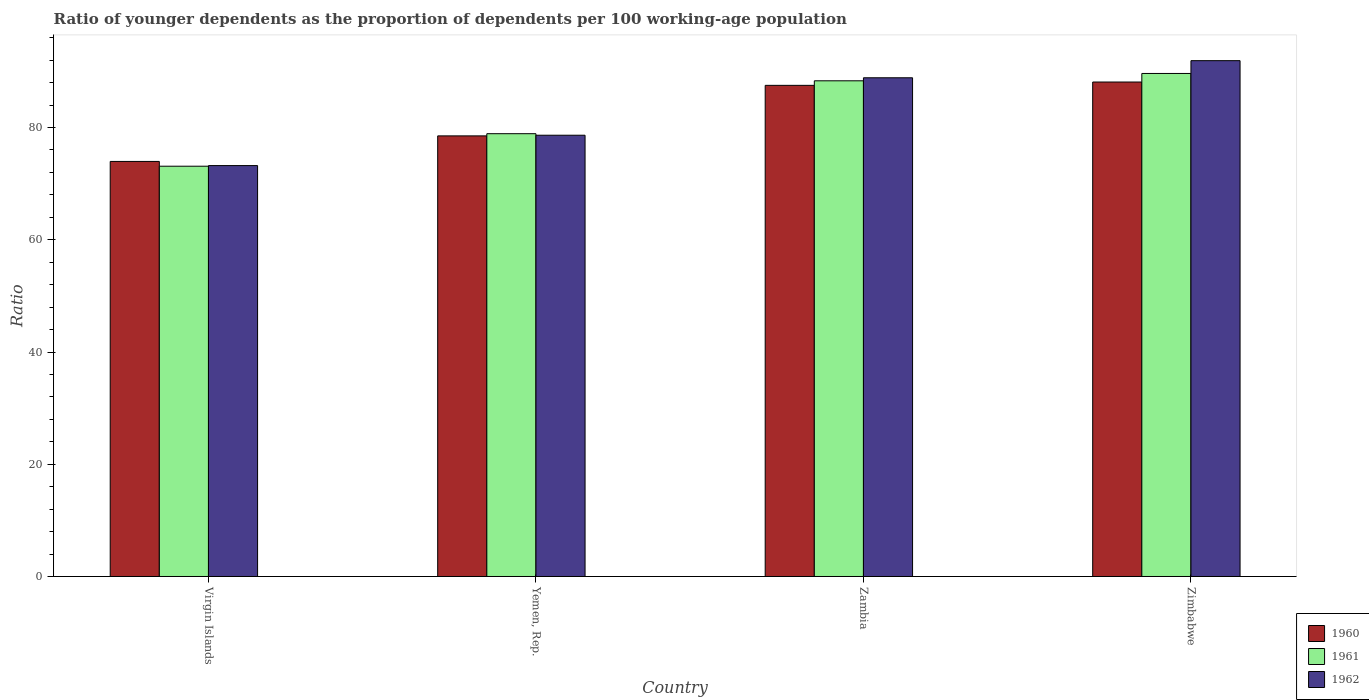How many groups of bars are there?
Ensure brevity in your answer.  4. Are the number of bars per tick equal to the number of legend labels?
Give a very brief answer. Yes. Are the number of bars on each tick of the X-axis equal?
Offer a very short reply. Yes. How many bars are there on the 3rd tick from the right?
Keep it short and to the point. 3. What is the label of the 1st group of bars from the left?
Your answer should be compact. Virgin Islands. In how many cases, is the number of bars for a given country not equal to the number of legend labels?
Ensure brevity in your answer.  0. What is the age dependency ratio(young) in 1960 in Zambia?
Offer a very short reply. 87.51. Across all countries, what is the maximum age dependency ratio(young) in 1962?
Offer a very short reply. 91.91. Across all countries, what is the minimum age dependency ratio(young) in 1962?
Ensure brevity in your answer.  73.22. In which country was the age dependency ratio(young) in 1962 maximum?
Your answer should be very brief. Zimbabwe. In which country was the age dependency ratio(young) in 1961 minimum?
Provide a succinct answer. Virgin Islands. What is the total age dependency ratio(young) in 1961 in the graph?
Provide a succinct answer. 329.97. What is the difference between the age dependency ratio(young) in 1961 in Virgin Islands and that in Zambia?
Your answer should be very brief. -15.22. What is the difference between the age dependency ratio(young) in 1962 in Zimbabwe and the age dependency ratio(young) in 1961 in Virgin Islands?
Offer a very short reply. 18.81. What is the average age dependency ratio(young) in 1961 per country?
Make the answer very short. 82.49. What is the difference between the age dependency ratio(young) of/in 1960 and age dependency ratio(young) of/in 1962 in Zambia?
Make the answer very short. -1.35. In how many countries, is the age dependency ratio(young) in 1961 greater than 28?
Provide a succinct answer. 4. What is the ratio of the age dependency ratio(young) in 1960 in Virgin Islands to that in Yemen, Rep.?
Provide a succinct answer. 0.94. What is the difference between the highest and the second highest age dependency ratio(young) in 1960?
Ensure brevity in your answer.  9.6. What is the difference between the highest and the lowest age dependency ratio(young) in 1960?
Keep it short and to the point. 14.15. What does the 1st bar from the left in Virgin Islands represents?
Offer a very short reply. 1960. What does the 3rd bar from the right in Yemen, Rep. represents?
Your response must be concise. 1960. How many countries are there in the graph?
Ensure brevity in your answer.  4. What is the difference between two consecutive major ticks on the Y-axis?
Keep it short and to the point. 20. Are the values on the major ticks of Y-axis written in scientific E-notation?
Ensure brevity in your answer.  No. Does the graph contain any zero values?
Keep it short and to the point. No. Where does the legend appear in the graph?
Offer a terse response. Bottom right. How many legend labels are there?
Ensure brevity in your answer.  3. What is the title of the graph?
Ensure brevity in your answer.  Ratio of younger dependents as the proportion of dependents per 100 working-age population. What is the label or title of the Y-axis?
Your response must be concise. Ratio. What is the Ratio in 1960 in Virgin Islands?
Your response must be concise. 73.96. What is the Ratio of 1961 in Virgin Islands?
Offer a terse response. 73.11. What is the Ratio of 1962 in Virgin Islands?
Make the answer very short. 73.22. What is the Ratio of 1960 in Yemen, Rep.?
Your answer should be compact. 78.51. What is the Ratio of 1961 in Yemen, Rep.?
Offer a terse response. 78.9. What is the Ratio of 1962 in Yemen, Rep.?
Ensure brevity in your answer.  78.63. What is the Ratio of 1960 in Zambia?
Provide a short and direct response. 87.51. What is the Ratio in 1961 in Zambia?
Provide a short and direct response. 88.32. What is the Ratio of 1962 in Zambia?
Your answer should be very brief. 88.86. What is the Ratio of 1960 in Zimbabwe?
Make the answer very short. 88.11. What is the Ratio of 1961 in Zimbabwe?
Offer a very short reply. 89.63. What is the Ratio of 1962 in Zimbabwe?
Offer a very short reply. 91.91. Across all countries, what is the maximum Ratio of 1960?
Your answer should be compact. 88.11. Across all countries, what is the maximum Ratio of 1961?
Your response must be concise. 89.63. Across all countries, what is the maximum Ratio in 1962?
Your response must be concise. 91.91. Across all countries, what is the minimum Ratio in 1960?
Your answer should be compact. 73.96. Across all countries, what is the minimum Ratio in 1961?
Your answer should be very brief. 73.11. Across all countries, what is the minimum Ratio of 1962?
Provide a succinct answer. 73.22. What is the total Ratio in 1960 in the graph?
Offer a very short reply. 328.09. What is the total Ratio of 1961 in the graph?
Offer a terse response. 329.97. What is the total Ratio in 1962 in the graph?
Make the answer very short. 332.62. What is the difference between the Ratio of 1960 in Virgin Islands and that in Yemen, Rep.?
Your response must be concise. -4.55. What is the difference between the Ratio of 1961 in Virgin Islands and that in Yemen, Rep.?
Give a very brief answer. -5.79. What is the difference between the Ratio of 1962 in Virgin Islands and that in Yemen, Rep.?
Your answer should be very brief. -5.41. What is the difference between the Ratio in 1960 in Virgin Islands and that in Zambia?
Your answer should be compact. -13.56. What is the difference between the Ratio in 1961 in Virgin Islands and that in Zambia?
Ensure brevity in your answer.  -15.22. What is the difference between the Ratio in 1962 in Virgin Islands and that in Zambia?
Provide a short and direct response. -15.64. What is the difference between the Ratio of 1960 in Virgin Islands and that in Zimbabwe?
Provide a short and direct response. -14.15. What is the difference between the Ratio of 1961 in Virgin Islands and that in Zimbabwe?
Your answer should be very brief. -16.52. What is the difference between the Ratio in 1962 in Virgin Islands and that in Zimbabwe?
Offer a terse response. -18.69. What is the difference between the Ratio in 1960 in Yemen, Rep. and that in Zambia?
Your answer should be very brief. -9.01. What is the difference between the Ratio of 1961 in Yemen, Rep. and that in Zambia?
Your response must be concise. -9.42. What is the difference between the Ratio in 1962 in Yemen, Rep. and that in Zambia?
Ensure brevity in your answer.  -10.24. What is the difference between the Ratio in 1960 in Yemen, Rep. and that in Zimbabwe?
Provide a succinct answer. -9.6. What is the difference between the Ratio of 1961 in Yemen, Rep. and that in Zimbabwe?
Provide a succinct answer. -10.73. What is the difference between the Ratio in 1962 in Yemen, Rep. and that in Zimbabwe?
Ensure brevity in your answer.  -13.29. What is the difference between the Ratio in 1960 in Zambia and that in Zimbabwe?
Provide a short and direct response. -0.59. What is the difference between the Ratio in 1961 in Zambia and that in Zimbabwe?
Offer a terse response. -1.31. What is the difference between the Ratio in 1962 in Zambia and that in Zimbabwe?
Offer a terse response. -3.05. What is the difference between the Ratio of 1960 in Virgin Islands and the Ratio of 1961 in Yemen, Rep.?
Offer a very short reply. -4.94. What is the difference between the Ratio of 1960 in Virgin Islands and the Ratio of 1962 in Yemen, Rep.?
Your response must be concise. -4.67. What is the difference between the Ratio in 1961 in Virgin Islands and the Ratio in 1962 in Yemen, Rep.?
Provide a succinct answer. -5.52. What is the difference between the Ratio of 1960 in Virgin Islands and the Ratio of 1961 in Zambia?
Offer a very short reply. -14.37. What is the difference between the Ratio in 1960 in Virgin Islands and the Ratio in 1962 in Zambia?
Provide a short and direct response. -14.9. What is the difference between the Ratio of 1961 in Virgin Islands and the Ratio of 1962 in Zambia?
Your response must be concise. -15.76. What is the difference between the Ratio of 1960 in Virgin Islands and the Ratio of 1961 in Zimbabwe?
Offer a very short reply. -15.67. What is the difference between the Ratio in 1960 in Virgin Islands and the Ratio in 1962 in Zimbabwe?
Your answer should be compact. -17.95. What is the difference between the Ratio of 1961 in Virgin Islands and the Ratio of 1962 in Zimbabwe?
Keep it short and to the point. -18.81. What is the difference between the Ratio of 1960 in Yemen, Rep. and the Ratio of 1961 in Zambia?
Offer a very short reply. -9.82. What is the difference between the Ratio in 1960 in Yemen, Rep. and the Ratio in 1962 in Zambia?
Give a very brief answer. -10.35. What is the difference between the Ratio in 1961 in Yemen, Rep. and the Ratio in 1962 in Zambia?
Ensure brevity in your answer.  -9.96. What is the difference between the Ratio of 1960 in Yemen, Rep. and the Ratio of 1961 in Zimbabwe?
Keep it short and to the point. -11.12. What is the difference between the Ratio of 1960 in Yemen, Rep. and the Ratio of 1962 in Zimbabwe?
Your answer should be very brief. -13.4. What is the difference between the Ratio in 1961 in Yemen, Rep. and the Ratio in 1962 in Zimbabwe?
Provide a short and direct response. -13.01. What is the difference between the Ratio in 1960 in Zambia and the Ratio in 1961 in Zimbabwe?
Your answer should be very brief. -2.12. What is the difference between the Ratio of 1960 in Zambia and the Ratio of 1962 in Zimbabwe?
Offer a very short reply. -4.4. What is the difference between the Ratio in 1961 in Zambia and the Ratio in 1962 in Zimbabwe?
Your response must be concise. -3.59. What is the average Ratio of 1960 per country?
Your answer should be compact. 82.02. What is the average Ratio in 1961 per country?
Give a very brief answer. 82.49. What is the average Ratio of 1962 per country?
Your answer should be very brief. 83.16. What is the difference between the Ratio of 1960 and Ratio of 1961 in Virgin Islands?
Provide a succinct answer. 0.85. What is the difference between the Ratio in 1960 and Ratio in 1962 in Virgin Islands?
Offer a very short reply. 0.74. What is the difference between the Ratio in 1961 and Ratio in 1962 in Virgin Islands?
Give a very brief answer. -0.11. What is the difference between the Ratio in 1960 and Ratio in 1961 in Yemen, Rep.?
Your answer should be very brief. -0.39. What is the difference between the Ratio in 1960 and Ratio in 1962 in Yemen, Rep.?
Your answer should be very brief. -0.12. What is the difference between the Ratio in 1961 and Ratio in 1962 in Yemen, Rep.?
Provide a short and direct response. 0.27. What is the difference between the Ratio in 1960 and Ratio in 1961 in Zambia?
Provide a succinct answer. -0.81. What is the difference between the Ratio in 1960 and Ratio in 1962 in Zambia?
Your response must be concise. -1.35. What is the difference between the Ratio of 1961 and Ratio of 1962 in Zambia?
Provide a succinct answer. -0.54. What is the difference between the Ratio of 1960 and Ratio of 1961 in Zimbabwe?
Offer a terse response. -1.52. What is the difference between the Ratio of 1960 and Ratio of 1962 in Zimbabwe?
Provide a succinct answer. -3.81. What is the difference between the Ratio in 1961 and Ratio in 1962 in Zimbabwe?
Provide a short and direct response. -2.28. What is the ratio of the Ratio in 1960 in Virgin Islands to that in Yemen, Rep.?
Provide a succinct answer. 0.94. What is the ratio of the Ratio in 1961 in Virgin Islands to that in Yemen, Rep.?
Your answer should be compact. 0.93. What is the ratio of the Ratio of 1962 in Virgin Islands to that in Yemen, Rep.?
Make the answer very short. 0.93. What is the ratio of the Ratio of 1960 in Virgin Islands to that in Zambia?
Make the answer very short. 0.85. What is the ratio of the Ratio in 1961 in Virgin Islands to that in Zambia?
Provide a succinct answer. 0.83. What is the ratio of the Ratio of 1962 in Virgin Islands to that in Zambia?
Your answer should be very brief. 0.82. What is the ratio of the Ratio in 1960 in Virgin Islands to that in Zimbabwe?
Offer a terse response. 0.84. What is the ratio of the Ratio of 1961 in Virgin Islands to that in Zimbabwe?
Offer a very short reply. 0.82. What is the ratio of the Ratio in 1962 in Virgin Islands to that in Zimbabwe?
Offer a very short reply. 0.8. What is the ratio of the Ratio in 1960 in Yemen, Rep. to that in Zambia?
Provide a short and direct response. 0.9. What is the ratio of the Ratio of 1961 in Yemen, Rep. to that in Zambia?
Keep it short and to the point. 0.89. What is the ratio of the Ratio in 1962 in Yemen, Rep. to that in Zambia?
Offer a very short reply. 0.88. What is the ratio of the Ratio in 1960 in Yemen, Rep. to that in Zimbabwe?
Offer a terse response. 0.89. What is the ratio of the Ratio of 1961 in Yemen, Rep. to that in Zimbabwe?
Your answer should be very brief. 0.88. What is the ratio of the Ratio in 1962 in Yemen, Rep. to that in Zimbabwe?
Provide a succinct answer. 0.86. What is the ratio of the Ratio in 1961 in Zambia to that in Zimbabwe?
Offer a terse response. 0.99. What is the ratio of the Ratio in 1962 in Zambia to that in Zimbabwe?
Your response must be concise. 0.97. What is the difference between the highest and the second highest Ratio in 1960?
Provide a short and direct response. 0.59. What is the difference between the highest and the second highest Ratio in 1961?
Offer a very short reply. 1.31. What is the difference between the highest and the second highest Ratio in 1962?
Your response must be concise. 3.05. What is the difference between the highest and the lowest Ratio of 1960?
Give a very brief answer. 14.15. What is the difference between the highest and the lowest Ratio in 1961?
Offer a terse response. 16.52. What is the difference between the highest and the lowest Ratio of 1962?
Your answer should be very brief. 18.69. 